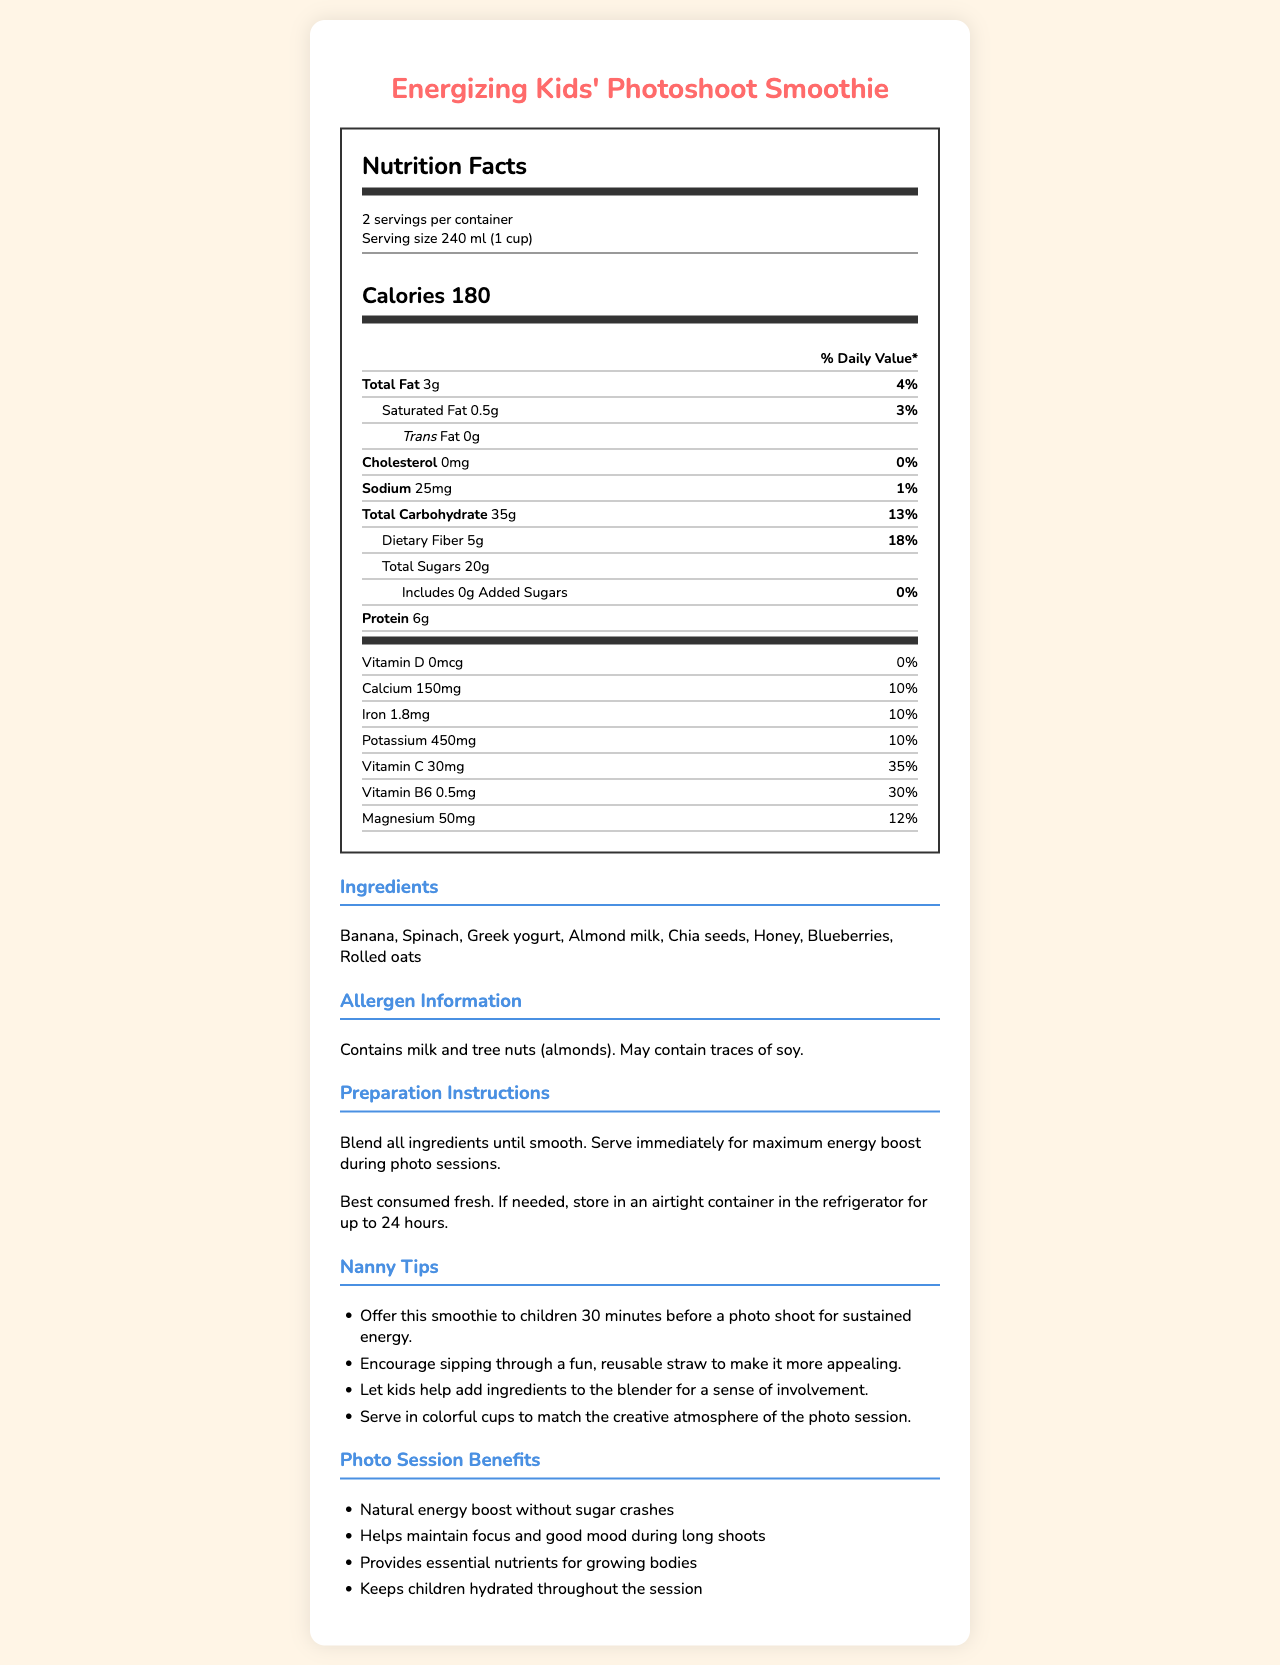what is the serving size? The serving size is clearly mentioned in the document as "240 ml (1 cup)".
Answer: 240 ml (1 cup) how many servings are there per container? The document specifies that there are 2 servings per container.
Answer: 2 how many calories are in one serving? The document lists the calorie content as 180 per serving.
Answer: 180 how much protein does one serving contain? The document indicates that each serving contains 6g of protein.
Answer: 6g what ingredients are in the smoothie? The ingredients list in the document includes Banana, Spinach, Greek yogurt, Almond milk, Chia seeds, Honey, Blueberries, and Rolled oats.
Answer: Banana, Spinach, Greek yogurt, Almond milk, Chia seeds, Honey, Blueberries, Rolled oats how much dietary fiber does one serving provide? The document shows that one serving provides 5g of dietary fiber.
Answer: 5g what percentage of daily value does vitamin C represent per serving? The document states that vitamin C represents 35% of the daily value per serving.
Answer: 35% does the smoothie contain any added sugars? The document clearly mentions that the smoothie contains 0g of added sugars.
Answer: No what are some of the benefits of the smoothie during photo sessions? The document lists several benefits during photo sessions, including a natural energy boost, maintaining focus and good mood, providing essential nutrients, and keeping children hydrated.
Answer: Natural energy boost without sugar crashes, Helps maintain focus and good mood during long shoots, Provides essential nutrients for growing bodies, Keeps children hydrated throughout the session how much calcium is in one serving? A. 150mg B. 200mg C. 250mg The document specifies that one serving contains 150mg of calcium.
Answer: A which of the following is a nanny tip for serving the smoothie? A. Serve with a slice of lemon B. Offer this smoothie to children 30 minutes before a photo shoot for sustained energy C. Mix with soda for extra fizz The document provides several nanny tips, including offering the smoothie to children 30 minutes before a photo shoot for sustained energy.
Answer: B does the smoothie contain any allergens? The document mentions that the smoothie contains milk and tree nuts (almonds), and it may contain traces of soy.
Answer: Yes is the daily value percentage for magnesium higher than for iron? The document shows that the daily value percentage for magnesium is 12% while for iron it is 10%.
Answer: No how should the smoothie be stored if not consumed immediately? The document advises storing the smoothie in an airtight container in the refrigerator for up to 24 hours if not consumed immediately.
Answer: Store in an airtight container in the refrigerator for up to 24 hours summarize the main idea of the document. The main focus of the document is to describe the nutritional value and benefits of the Energizing Kids' Photoshoot Smoothie and how it can help boost children's energy and mood during photo shoots.
Answer: The document provides a detailed overview of the Energizing Kids' Photoshoot Smoothie, including its nutritional facts, ingredients, allergen information, preparation and storage instructions, nanny tips for serving, and the benefits for children during photo sessions. what is the source of potassium in the smoothie? The document does not specify which ingredient contributes potassium to the smoothie, so the source cannot be determined.
Answer: Cannot be determined 